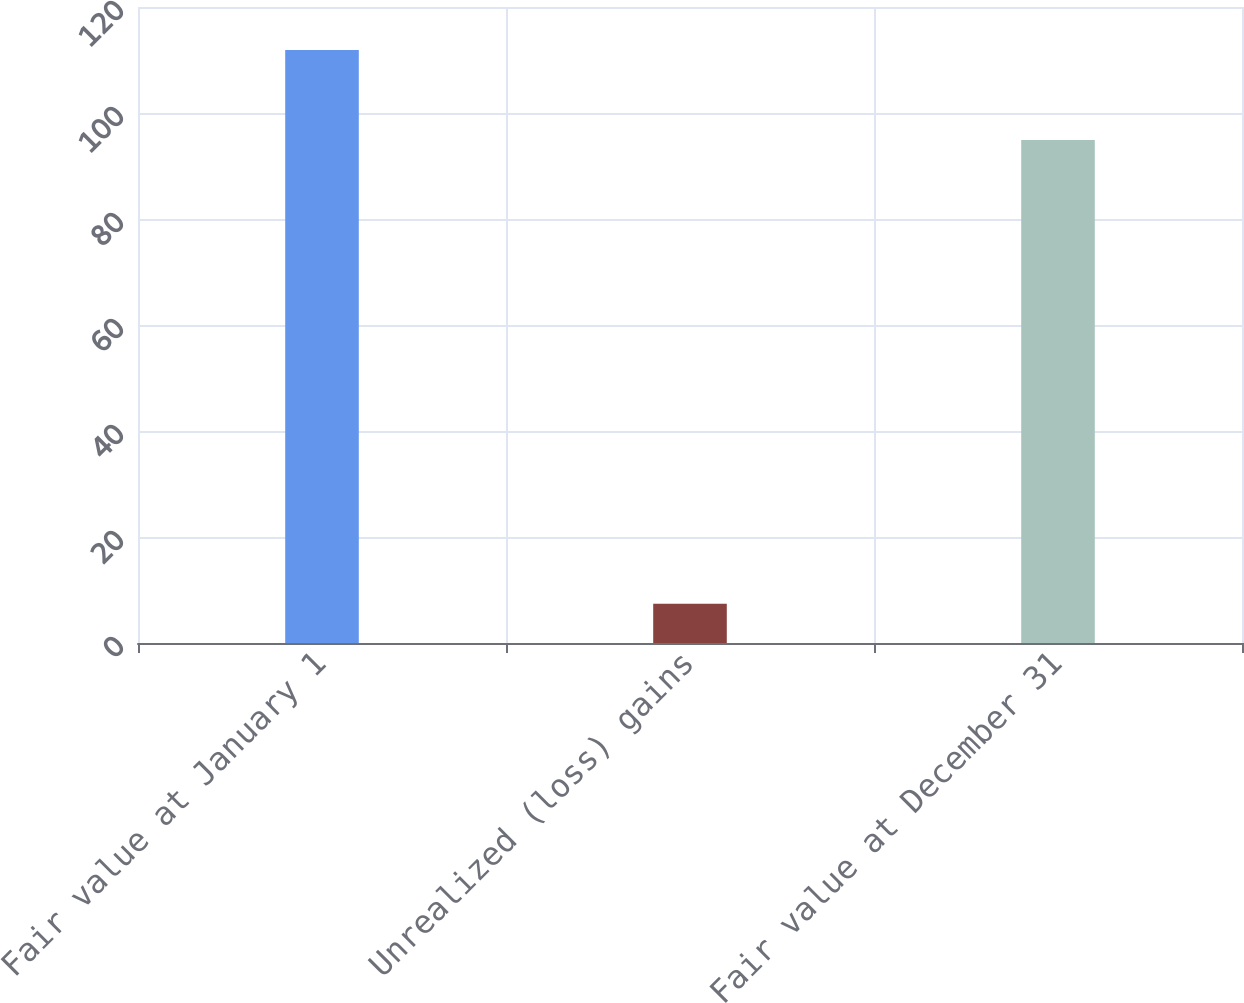Convert chart to OTSL. <chart><loc_0><loc_0><loc_500><loc_500><bar_chart><fcel>Fair value at January 1<fcel>Unrealized (loss) gains<fcel>Fair value at December 31<nl><fcel>111.9<fcel>7.4<fcel>94.9<nl></chart> 